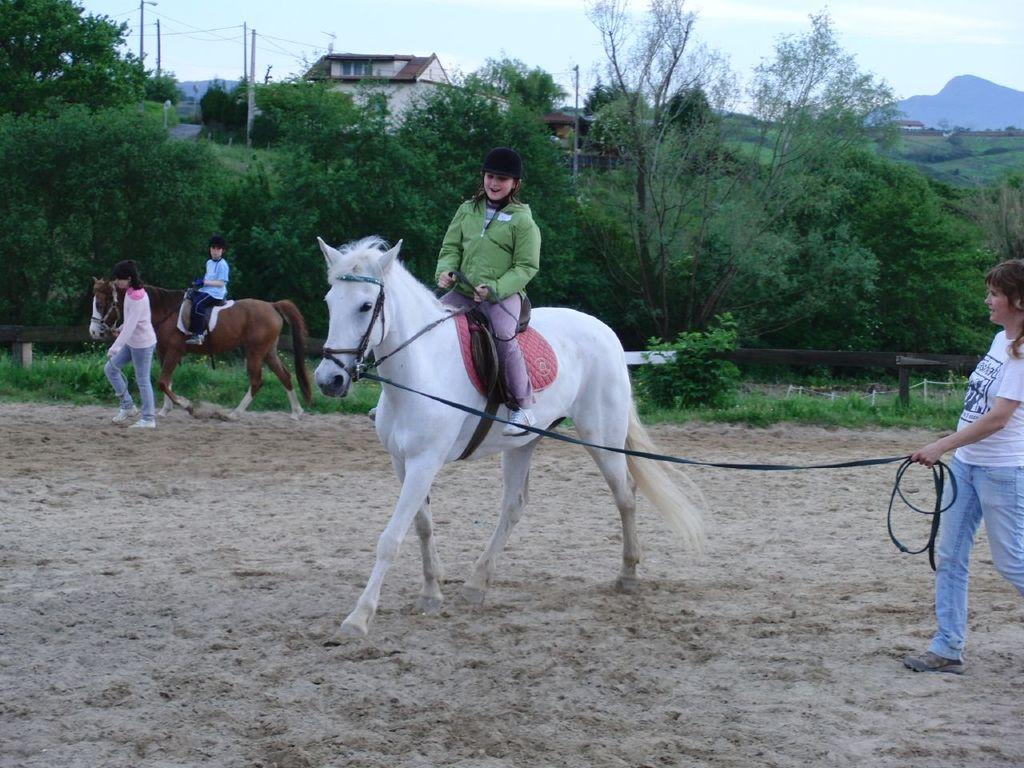How many kids are in the image? There are two kids in the image. What are the kids doing in the image? Each kid is sitting on a different horse. Who is assisting the kids with the horses? There are two persons holding a belt that is tightened to the horses. What can be seen in the background of the image? There are trees and a building in the background of the image. What type of dirt can be seen on the quince in the image? There is no quince or dirt present in the image. How many potatoes are visible in the image? There are no potatoes present in the image. 